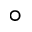<formula> <loc_0><loc_0><loc_500><loc_500>\circ</formula> 